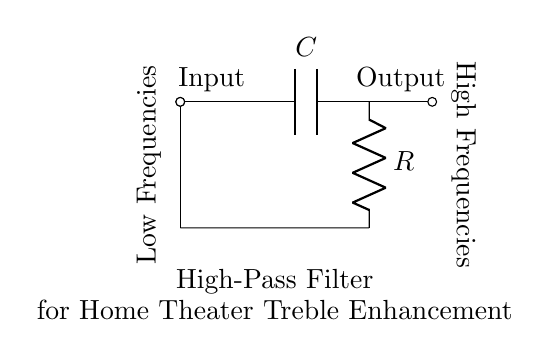What are the components of this circuit? The circuit consists of a capacitor and a resistor. These two components are connected in series.
Answer: capacitor and resistor What is the function of this filter? This filter allows high frequencies to pass while attenuating low frequencies, enhancing treble in a home theater system.
Answer: high-pass filter Where is the input located in the circuit? The input is at the left side of the circuit, where the signal enters before passing through the capacitor.
Answer: left side Why does the output produce high frequencies? The capacitor blocks low frequencies due to its reactance at lower frequencies, while allowing high frequencies to pass through to the output.
Answer: capacitor What does the term 'low frequencies' refer to in this filter? 'Low frequencies' refers to audio signals that fall below the cutoff frequency of the filter, which are attenuated as they pass through the circuit.
Answer: audio signals below cutoff frequency What can be said about the circuit’s frequency response? The frequency response of this high-pass filter shows that signals above a certain frequency are transmitted with less attenuation, while those below are significantly reduced.
Answer: signals above cutoff transmitted What is the output placement in the diagram? The output is positioned on the right side, after the resistor, where the enhanced treble frequencies are available.
Answer: right side 